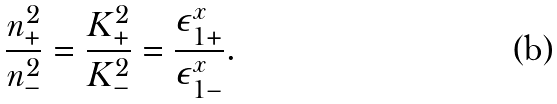<formula> <loc_0><loc_0><loc_500><loc_500>\frac { n ^ { 2 } _ { + } } { n ^ { 2 } _ { - } } = \frac { K ^ { 2 } _ { + } } { K ^ { 2 } _ { - } } = \frac { \epsilon ^ { x } _ { 1 + } } { \epsilon ^ { x } _ { 1 - } } .</formula> 